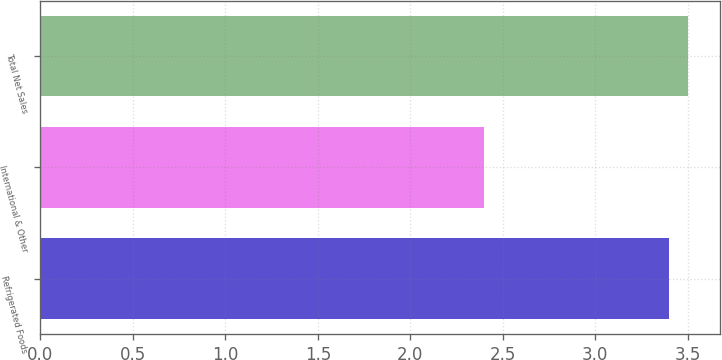Convert chart to OTSL. <chart><loc_0><loc_0><loc_500><loc_500><bar_chart><fcel>Refrigerated Foods<fcel>International & Other<fcel>Total Net Sales<nl><fcel>3.4<fcel>2.4<fcel>3.5<nl></chart> 